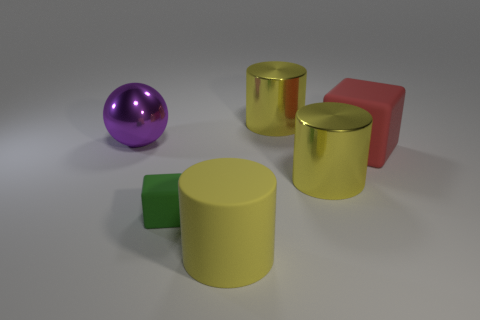Subtract all big metallic cylinders. How many cylinders are left? 1 Add 2 large gray matte balls. How many objects exist? 8 Subtract all cyan cylinders. Subtract all red spheres. How many cylinders are left? 3 Subtract all cubes. How many objects are left? 4 Subtract all large cubes. Subtract all rubber objects. How many objects are left? 2 Add 3 big yellow metallic objects. How many big yellow metallic objects are left? 5 Add 6 brown matte blocks. How many brown matte blocks exist? 6 Subtract 1 red blocks. How many objects are left? 5 